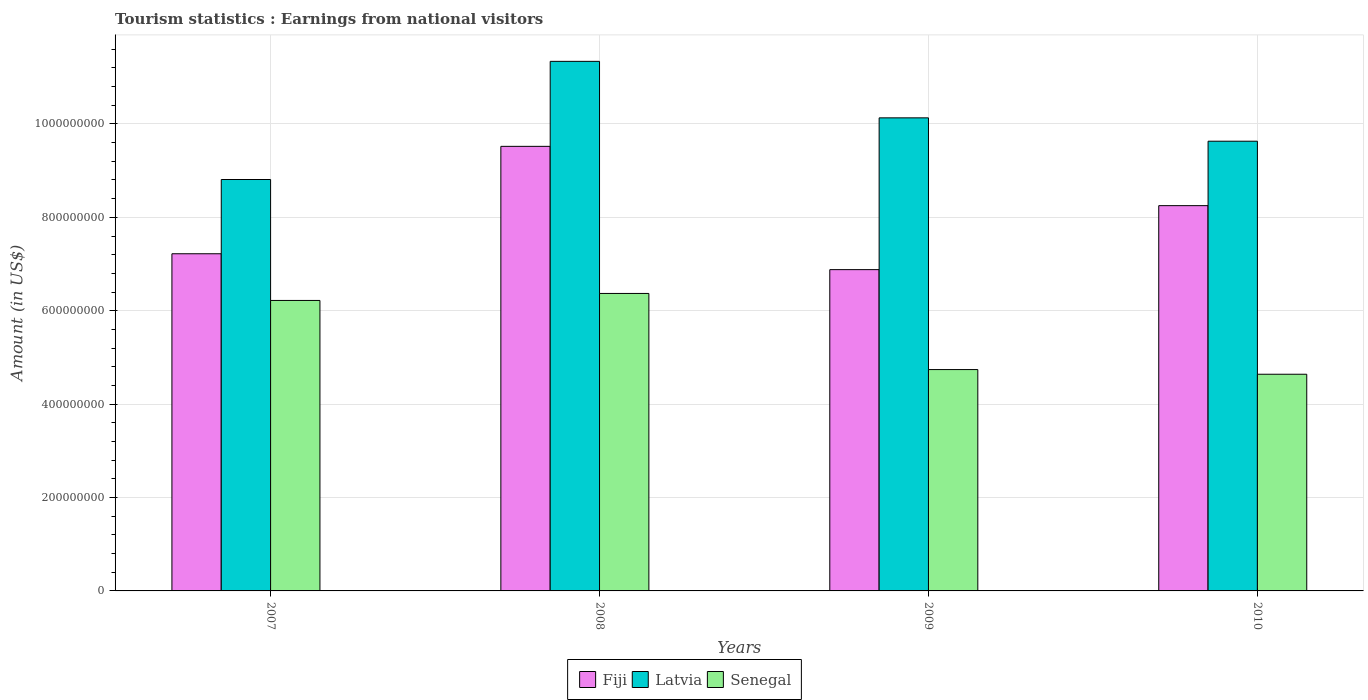How many different coloured bars are there?
Offer a very short reply. 3. How many groups of bars are there?
Provide a short and direct response. 4. Are the number of bars per tick equal to the number of legend labels?
Offer a terse response. Yes. How many bars are there on the 2nd tick from the right?
Keep it short and to the point. 3. What is the earnings from national visitors in Fiji in 2010?
Provide a short and direct response. 8.25e+08. Across all years, what is the maximum earnings from national visitors in Senegal?
Give a very brief answer. 6.37e+08. Across all years, what is the minimum earnings from national visitors in Fiji?
Give a very brief answer. 6.88e+08. In which year was the earnings from national visitors in Latvia minimum?
Your answer should be very brief. 2007. What is the total earnings from national visitors in Senegal in the graph?
Offer a terse response. 2.20e+09. What is the difference between the earnings from national visitors in Fiji in 2008 and that in 2009?
Your answer should be very brief. 2.64e+08. What is the difference between the earnings from national visitors in Latvia in 2010 and the earnings from national visitors in Fiji in 2009?
Ensure brevity in your answer.  2.75e+08. What is the average earnings from national visitors in Fiji per year?
Offer a very short reply. 7.97e+08. In the year 2007, what is the difference between the earnings from national visitors in Fiji and earnings from national visitors in Latvia?
Make the answer very short. -1.59e+08. What is the ratio of the earnings from national visitors in Fiji in 2007 to that in 2009?
Your answer should be compact. 1.05. Is the earnings from national visitors in Latvia in 2007 less than that in 2009?
Keep it short and to the point. Yes. Is the difference between the earnings from national visitors in Fiji in 2007 and 2008 greater than the difference between the earnings from national visitors in Latvia in 2007 and 2008?
Offer a very short reply. Yes. What is the difference between the highest and the second highest earnings from national visitors in Latvia?
Ensure brevity in your answer.  1.21e+08. What is the difference between the highest and the lowest earnings from national visitors in Latvia?
Make the answer very short. 2.53e+08. Is the sum of the earnings from national visitors in Latvia in 2007 and 2009 greater than the maximum earnings from national visitors in Senegal across all years?
Provide a short and direct response. Yes. What does the 3rd bar from the left in 2008 represents?
Your answer should be very brief. Senegal. What does the 3rd bar from the right in 2009 represents?
Keep it short and to the point. Fiji. How many bars are there?
Ensure brevity in your answer.  12. What is the difference between two consecutive major ticks on the Y-axis?
Offer a terse response. 2.00e+08. Are the values on the major ticks of Y-axis written in scientific E-notation?
Give a very brief answer. No. Does the graph contain grids?
Your answer should be compact. Yes. Where does the legend appear in the graph?
Keep it short and to the point. Bottom center. How are the legend labels stacked?
Ensure brevity in your answer.  Horizontal. What is the title of the graph?
Make the answer very short. Tourism statistics : Earnings from national visitors. Does "Europe(all income levels)" appear as one of the legend labels in the graph?
Provide a succinct answer. No. What is the Amount (in US$) of Fiji in 2007?
Offer a very short reply. 7.22e+08. What is the Amount (in US$) of Latvia in 2007?
Provide a succinct answer. 8.81e+08. What is the Amount (in US$) in Senegal in 2007?
Offer a very short reply. 6.22e+08. What is the Amount (in US$) of Fiji in 2008?
Keep it short and to the point. 9.52e+08. What is the Amount (in US$) of Latvia in 2008?
Ensure brevity in your answer.  1.13e+09. What is the Amount (in US$) of Senegal in 2008?
Your answer should be very brief. 6.37e+08. What is the Amount (in US$) in Fiji in 2009?
Make the answer very short. 6.88e+08. What is the Amount (in US$) in Latvia in 2009?
Offer a very short reply. 1.01e+09. What is the Amount (in US$) of Senegal in 2009?
Provide a short and direct response. 4.74e+08. What is the Amount (in US$) of Fiji in 2010?
Make the answer very short. 8.25e+08. What is the Amount (in US$) in Latvia in 2010?
Keep it short and to the point. 9.63e+08. What is the Amount (in US$) of Senegal in 2010?
Offer a very short reply. 4.64e+08. Across all years, what is the maximum Amount (in US$) of Fiji?
Make the answer very short. 9.52e+08. Across all years, what is the maximum Amount (in US$) of Latvia?
Provide a short and direct response. 1.13e+09. Across all years, what is the maximum Amount (in US$) in Senegal?
Ensure brevity in your answer.  6.37e+08. Across all years, what is the minimum Amount (in US$) of Fiji?
Make the answer very short. 6.88e+08. Across all years, what is the minimum Amount (in US$) of Latvia?
Your response must be concise. 8.81e+08. Across all years, what is the minimum Amount (in US$) in Senegal?
Your answer should be compact. 4.64e+08. What is the total Amount (in US$) of Fiji in the graph?
Offer a terse response. 3.19e+09. What is the total Amount (in US$) in Latvia in the graph?
Ensure brevity in your answer.  3.99e+09. What is the total Amount (in US$) in Senegal in the graph?
Provide a short and direct response. 2.20e+09. What is the difference between the Amount (in US$) in Fiji in 2007 and that in 2008?
Your answer should be very brief. -2.30e+08. What is the difference between the Amount (in US$) in Latvia in 2007 and that in 2008?
Your answer should be compact. -2.53e+08. What is the difference between the Amount (in US$) in Senegal in 2007 and that in 2008?
Keep it short and to the point. -1.50e+07. What is the difference between the Amount (in US$) of Fiji in 2007 and that in 2009?
Make the answer very short. 3.40e+07. What is the difference between the Amount (in US$) of Latvia in 2007 and that in 2009?
Offer a very short reply. -1.32e+08. What is the difference between the Amount (in US$) of Senegal in 2007 and that in 2009?
Ensure brevity in your answer.  1.48e+08. What is the difference between the Amount (in US$) of Fiji in 2007 and that in 2010?
Provide a succinct answer. -1.03e+08. What is the difference between the Amount (in US$) of Latvia in 2007 and that in 2010?
Your response must be concise. -8.20e+07. What is the difference between the Amount (in US$) in Senegal in 2007 and that in 2010?
Offer a very short reply. 1.58e+08. What is the difference between the Amount (in US$) in Fiji in 2008 and that in 2009?
Give a very brief answer. 2.64e+08. What is the difference between the Amount (in US$) in Latvia in 2008 and that in 2009?
Provide a short and direct response. 1.21e+08. What is the difference between the Amount (in US$) of Senegal in 2008 and that in 2009?
Provide a succinct answer. 1.63e+08. What is the difference between the Amount (in US$) of Fiji in 2008 and that in 2010?
Ensure brevity in your answer.  1.27e+08. What is the difference between the Amount (in US$) in Latvia in 2008 and that in 2010?
Give a very brief answer. 1.71e+08. What is the difference between the Amount (in US$) of Senegal in 2008 and that in 2010?
Ensure brevity in your answer.  1.73e+08. What is the difference between the Amount (in US$) of Fiji in 2009 and that in 2010?
Make the answer very short. -1.37e+08. What is the difference between the Amount (in US$) of Senegal in 2009 and that in 2010?
Provide a succinct answer. 1.00e+07. What is the difference between the Amount (in US$) of Fiji in 2007 and the Amount (in US$) of Latvia in 2008?
Your answer should be very brief. -4.12e+08. What is the difference between the Amount (in US$) of Fiji in 2007 and the Amount (in US$) of Senegal in 2008?
Your answer should be compact. 8.50e+07. What is the difference between the Amount (in US$) of Latvia in 2007 and the Amount (in US$) of Senegal in 2008?
Your response must be concise. 2.44e+08. What is the difference between the Amount (in US$) of Fiji in 2007 and the Amount (in US$) of Latvia in 2009?
Provide a succinct answer. -2.91e+08. What is the difference between the Amount (in US$) in Fiji in 2007 and the Amount (in US$) in Senegal in 2009?
Offer a very short reply. 2.48e+08. What is the difference between the Amount (in US$) of Latvia in 2007 and the Amount (in US$) of Senegal in 2009?
Offer a very short reply. 4.07e+08. What is the difference between the Amount (in US$) in Fiji in 2007 and the Amount (in US$) in Latvia in 2010?
Your response must be concise. -2.41e+08. What is the difference between the Amount (in US$) in Fiji in 2007 and the Amount (in US$) in Senegal in 2010?
Offer a terse response. 2.58e+08. What is the difference between the Amount (in US$) of Latvia in 2007 and the Amount (in US$) of Senegal in 2010?
Your response must be concise. 4.17e+08. What is the difference between the Amount (in US$) of Fiji in 2008 and the Amount (in US$) of Latvia in 2009?
Make the answer very short. -6.10e+07. What is the difference between the Amount (in US$) in Fiji in 2008 and the Amount (in US$) in Senegal in 2009?
Your answer should be very brief. 4.78e+08. What is the difference between the Amount (in US$) in Latvia in 2008 and the Amount (in US$) in Senegal in 2009?
Ensure brevity in your answer.  6.60e+08. What is the difference between the Amount (in US$) of Fiji in 2008 and the Amount (in US$) of Latvia in 2010?
Keep it short and to the point. -1.10e+07. What is the difference between the Amount (in US$) of Fiji in 2008 and the Amount (in US$) of Senegal in 2010?
Provide a short and direct response. 4.88e+08. What is the difference between the Amount (in US$) of Latvia in 2008 and the Amount (in US$) of Senegal in 2010?
Make the answer very short. 6.70e+08. What is the difference between the Amount (in US$) of Fiji in 2009 and the Amount (in US$) of Latvia in 2010?
Keep it short and to the point. -2.75e+08. What is the difference between the Amount (in US$) in Fiji in 2009 and the Amount (in US$) in Senegal in 2010?
Ensure brevity in your answer.  2.24e+08. What is the difference between the Amount (in US$) of Latvia in 2009 and the Amount (in US$) of Senegal in 2010?
Your answer should be compact. 5.49e+08. What is the average Amount (in US$) in Fiji per year?
Give a very brief answer. 7.97e+08. What is the average Amount (in US$) of Latvia per year?
Make the answer very short. 9.98e+08. What is the average Amount (in US$) in Senegal per year?
Your answer should be very brief. 5.49e+08. In the year 2007, what is the difference between the Amount (in US$) in Fiji and Amount (in US$) in Latvia?
Provide a succinct answer. -1.59e+08. In the year 2007, what is the difference between the Amount (in US$) of Latvia and Amount (in US$) of Senegal?
Your answer should be compact. 2.59e+08. In the year 2008, what is the difference between the Amount (in US$) of Fiji and Amount (in US$) of Latvia?
Make the answer very short. -1.82e+08. In the year 2008, what is the difference between the Amount (in US$) in Fiji and Amount (in US$) in Senegal?
Make the answer very short. 3.15e+08. In the year 2008, what is the difference between the Amount (in US$) in Latvia and Amount (in US$) in Senegal?
Your response must be concise. 4.97e+08. In the year 2009, what is the difference between the Amount (in US$) of Fiji and Amount (in US$) of Latvia?
Your response must be concise. -3.25e+08. In the year 2009, what is the difference between the Amount (in US$) in Fiji and Amount (in US$) in Senegal?
Your answer should be compact. 2.14e+08. In the year 2009, what is the difference between the Amount (in US$) in Latvia and Amount (in US$) in Senegal?
Keep it short and to the point. 5.39e+08. In the year 2010, what is the difference between the Amount (in US$) of Fiji and Amount (in US$) of Latvia?
Provide a succinct answer. -1.38e+08. In the year 2010, what is the difference between the Amount (in US$) in Fiji and Amount (in US$) in Senegal?
Provide a short and direct response. 3.61e+08. In the year 2010, what is the difference between the Amount (in US$) of Latvia and Amount (in US$) of Senegal?
Your answer should be very brief. 4.99e+08. What is the ratio of the Amount (in US$) of Fiji in 2007 to that in 2008?
Your answer should be compact. 0.76. What is the ratio of the Amount (in US$) in Latvia in 2007 to that in 2008?
Give a very brief answer. 0.78. What is the ratio of the Amount (in US$) of Senegal in 2007 to that in 2008?
Keep it short and to the point. 0.98. What is the ratio of the Amount (in US$) of Fiji in 2007 to that in 2009?
Keep it short and to the point. 1.05. What is the ratio of the Amount (in US$) of Latvia in 2007 to that in 2009?
Your answer should be compact. 0.87. What is the ratio of the Amount (in US$) in Senegal in 2007 to that in 2009?
Make the answer very short. 1.31. What is the ratio of the Amount (in US$) in Fiji in 2007 to that in 2010?
Your answer should be compact. 0.88. What is the ratio of the Amount (in US$) of Latvia in 2007 to that in 2010?
Keep it short and to the point. 0.91. What is the ratio of the Amount (in US$) of Senegal in 2007 to that in 2010?
Keep it short and to the point. 1.34. What is the ratio of the Amount (in US$) in Fiji in 2008 to that in 2009?
Ensure brevity in your answer.  1.38. What is the ratio of the Amount (in US$) of Latvia in 2008 to that in 2009?
Make the answer very short. 1.12. What is the ratio of the Amount (in US$) in Senegal in 2008 to that in 2009?
Provide a succinct answer. 1.34. What is the ratio of the Amount (in US$) in Fiji in 2008 to that in 2010?
Provide a short and direct response. 1.15. What is the ratio of the Amount (in US$) in Latvia in 2008 to that in 2010?
Give a very brief answer. 1.18. What is the ratio of the Amount (in US$) of Senegal in 2008 to that in 2010?
Give a very brief answer. 1.37. What is the ratio of the Amount (in US$) in Fiji in 2009 to that in 2010?
Offer a terse response. 0.83. What is the ratio of the Amount (in US$) of Latvia in 2009 to that in 2010?
Provide a succinct answer. 1.05. What is the ratio of the Amount (in US$) of Senegal in 2009 to that in 2010?
Provide a succinct answer. 1.02. What is the difference between the highest and the second highest Amount (in US$) in Fiji?
Provide a succinct answer. 1.27e+08. What is the difference between the highest and the second highest Amount (in US$) in Latvia?
Your answer should be very brief. 1.21e+08. What is the difference between the highest and the second highest Amount (in US$) in Senegal?
Offer a terse response. 1.50e+07. What is the difference between the highest and the lowest Amount (in US$) of Fiji?
Your answer should be very brief. 2.64e+08. What is the difference between the highest and the lowest Amount (in US$) of Latvia?
Make the answer very short. 2.53e+08. What is the difference between the highest and the lowest Amount (in US$) of Senegal?
Provide a succinct answer. 1.73e+08. 